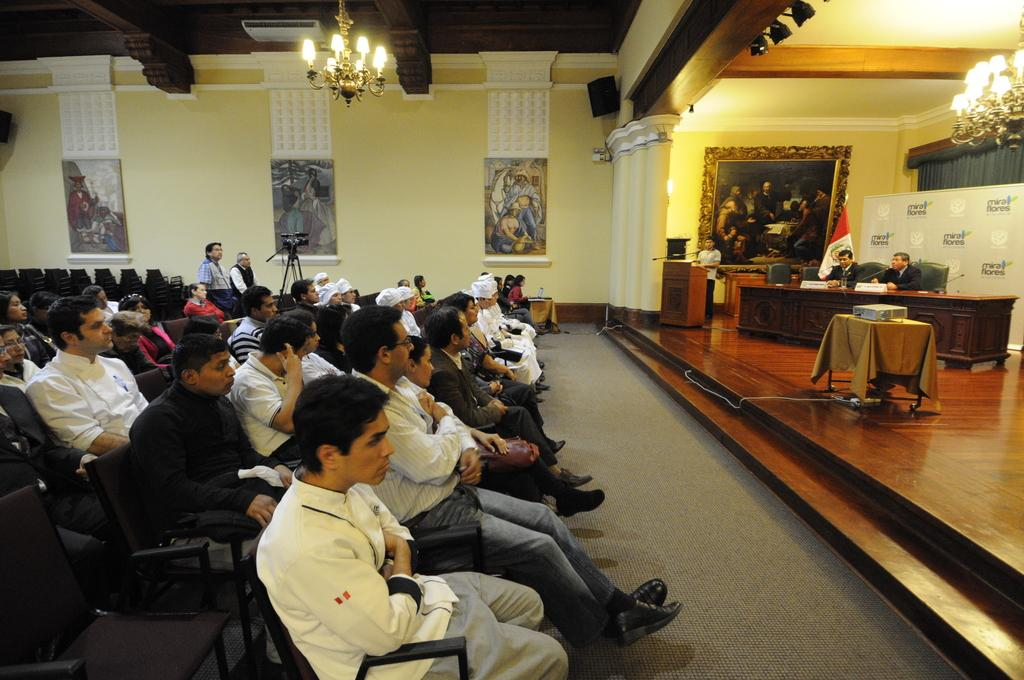What is happening on the left side of the image? There is a group of people sitting on chairs on the left side of the image. What can be seen at the top of the image? There is a light at the top of the image. What are the two people on the right side of the image doing? Two people are sitting on chairs on the right side of the image and are speaking. What is on the wall in the image? There are photos on the wall in the image. What type of skate is being used by the people in the image? There is no skate present in the image; it features a group of people sitting on chairs. What language are the two people on the right side of the image speaking? The image does not provide information about the language being spoken by the two people on the right side of the image. 